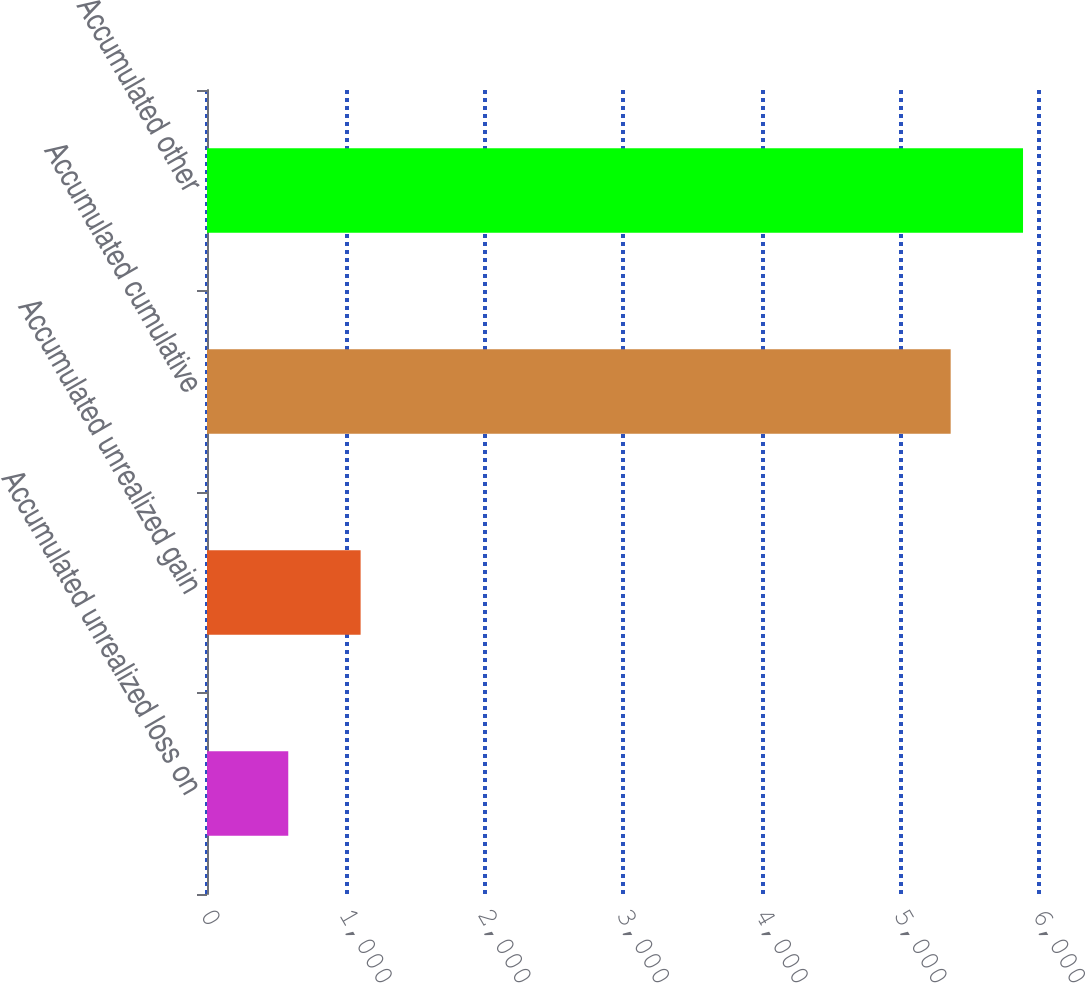Convert chart. <chart><loc_0><loc_0><loc_500><loc_500><bar_chart><fcel>Accumulated unrealized loss on<fcel>Accumulated unrealized gain<fcel>Accumulated cumulative<fcel>Accumulated other<nl><fcel>586<fcel>1107.8<fcel>5363<fcel>5884.8<nl></chart> 